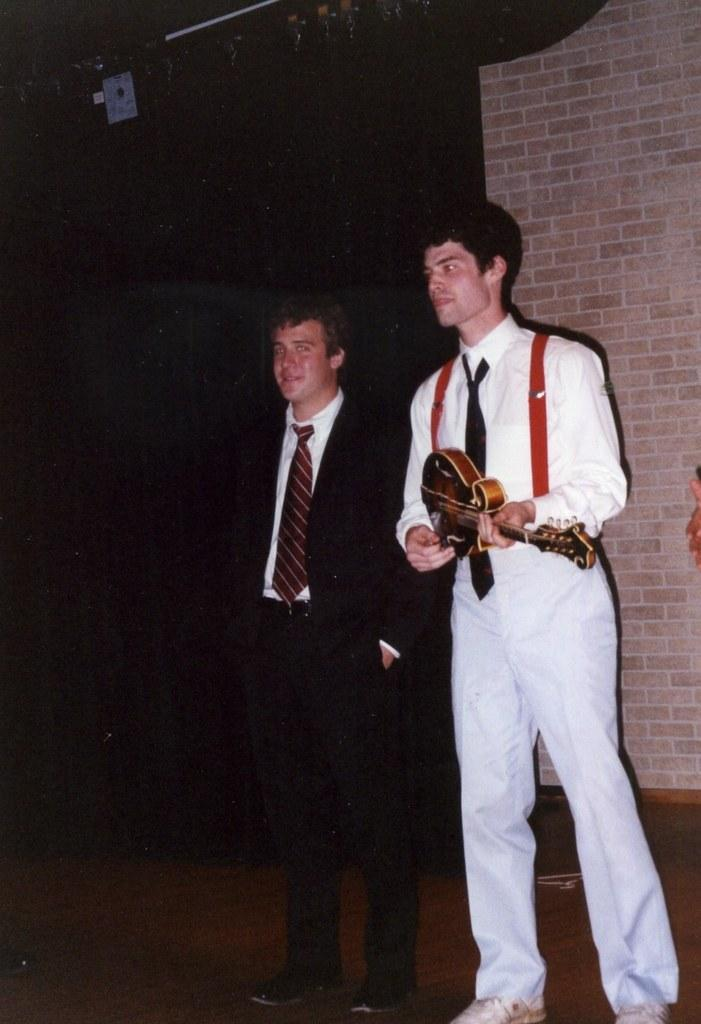How many people are in the image? There are two persons standing in the image. What is one of the persons holding? One of the persons is holding a guitar. What can be seen in the background of the image? The background of the image is dark. What type of structure is visible in the image? There is a wall visible in the image. Can you see any boats in the image? No, there are no boats present in the image. What type of berry is being used as a prop in the image? There is no berry present in the image. 